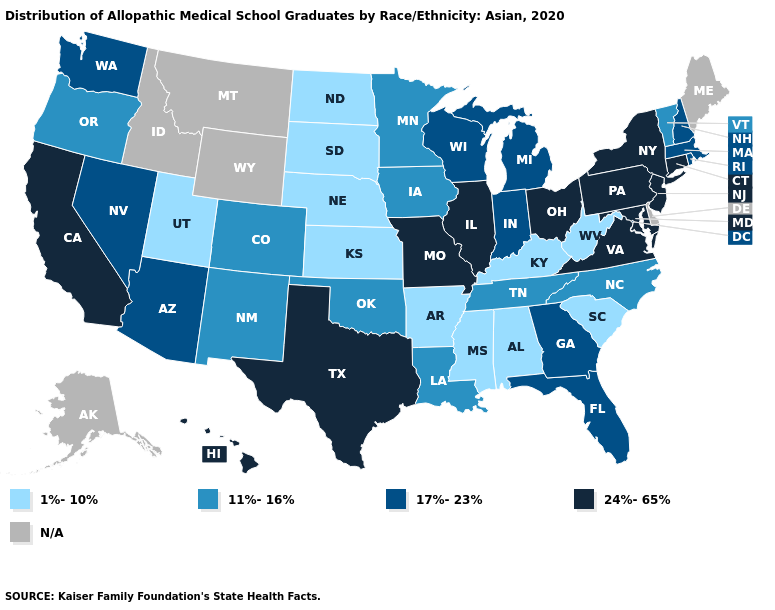Name the states that have a value in the range 1%-10%?
Answer briefly. Alabama, Arkansas, Kansas, Kentucky, Mississippi, Nebraska, North Dakota, South Carolina, South Dakota, Utah, West Virginia. Among the states that border Virginia , which have the highest value?
Short answer required. Maryland. Does the first symbol in the legend represent the smallest category?
Keep it brief. Yes. Does Vermont have the highest value in the Northeast?
Short answer required. No. What is the highest value in the USA?
Be succinct. 24%-65%. What is the value of New York?
Write a very short answer. 24%-65%. Name the states that have a value in the range N/A?
Quick response, please. Alaska, Delaware, Idaho, Maine, Montana, Wyoming. Does the map have missing data?
Quick response, please. Yes. How many symbols are there in the legend?
Quick response, please. 5. Name the states that have a value in the range 1%-10%?
Short answer required. Alabama, Arkansas, Kansas, Kentucky, Mississippi, Nebraska, North Dakota, South Carolina, South Dakota, Utah, West Virginia. Does Illinois have the highest value in the MidWest?
Concise answer only. Yes. Name the states that have a value in the range 11%-16%?
Keep it brief. Colorado, Iowa, Louisiana, Minnesota, New Mexico, North Carolina, Oklahoma, Oregon, Tennessee, Vermont. Among the states that border Kansas , which have the lowest value?
Write a very short answer. Nebraska. Name the states that have a value in the range 1%-10%?
Quick response, please. Alabama, Arkansas, Kansas, Kentucky, Mississippi, Nebraska, North Dakota, South Carolina, South Dakota, Utah, West Virginia. 